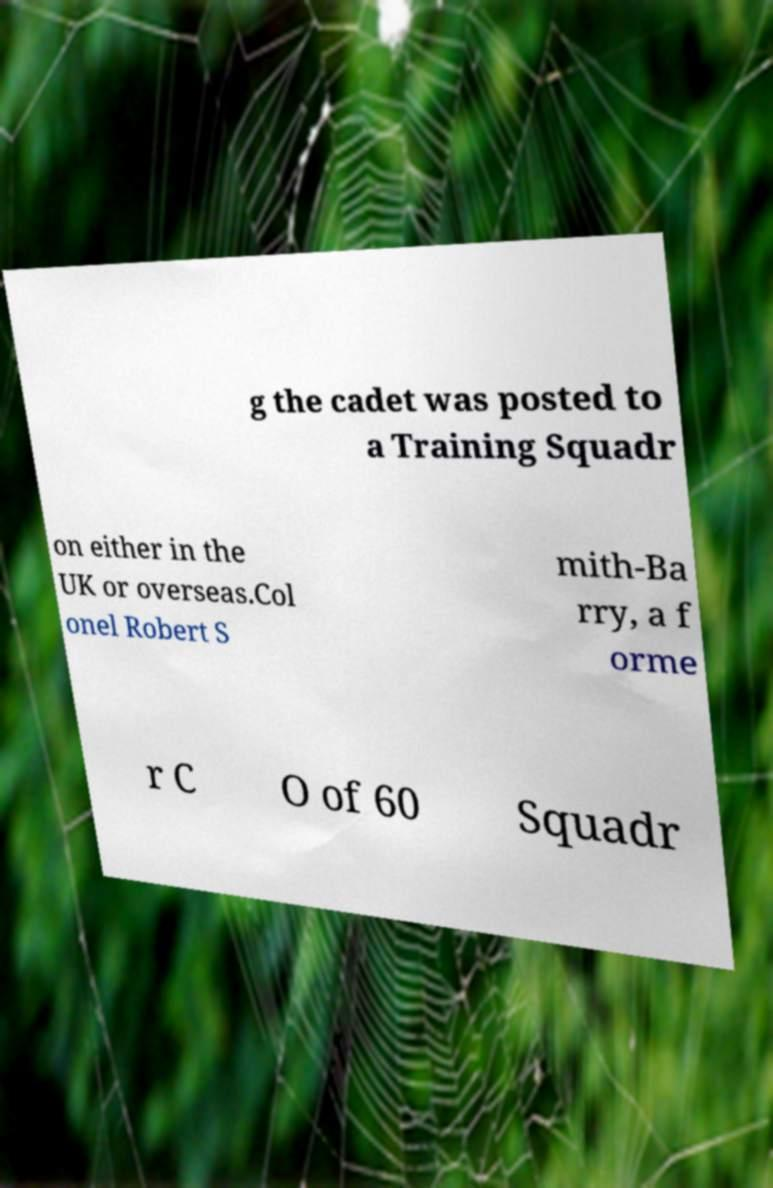Could you assist in decoding the text presented in this image and type it out clearly? g the cadet was posted to a Training Squadr on either in the UK or overseas.Col onel Robert S mith-Ba rry, a f orme r C O of 60 Squadr 